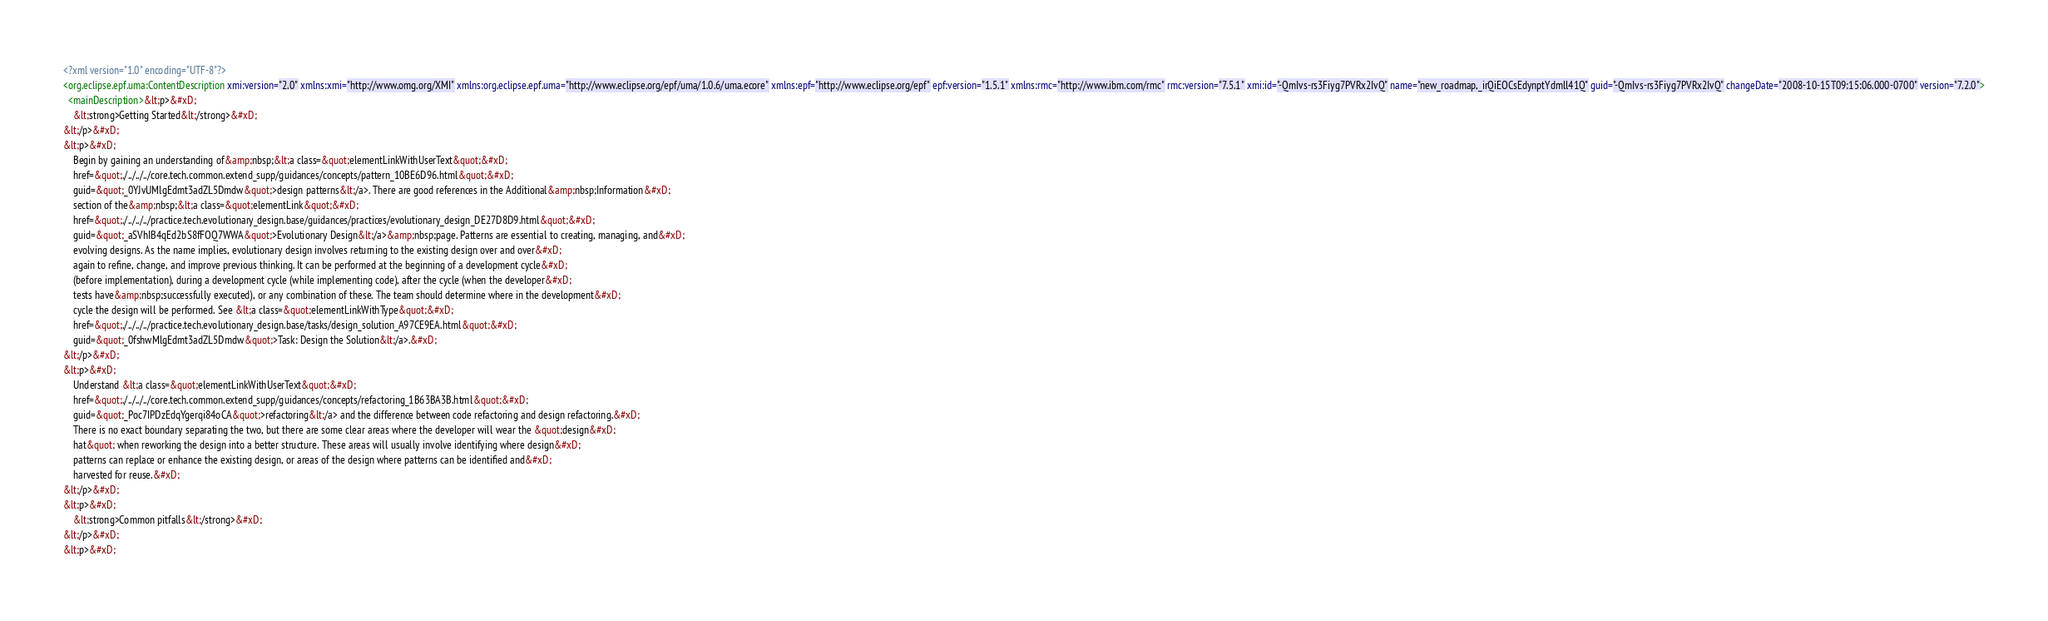<code> <loc_0><loc_0><loc_500><loc_500><_XML_><?xml version="1.0" encoding="UTF-8"?>
<org.eclipse.epf.uma:ContentDescription xmi:version="2.0" xmlns:xmi="http://www.omg.org/XMI" xmlns:org.eclipse.epf.uma="http://www.eclipse.org/epf/uma/1.0.6/uma.ecore" xmlns:epf="http://www.eclipse.org/epf" epf:version="1.5.1" xmlns:rmc="http://www.ibm.com/rmc" rmc:version="7.5.1" xmi:id="-QmIvs-rs3Fiyg7PVRx2IvQ" name="new_roadmap,_irQiEOCsEdynptYdmll41Q" guid="-QmIvs-rs3Fiyg7PVRx2IvQ" changeDate="2008-10-15T09:15:06.000-0700" version="7.2.0">
  <mainDescription>&lt;p>&#xD;
    &lt;strong>Getting Started&lt;/strong>&#xD;
&lt;/p>&#xD;
&lt;p>&#xD;
    Begin by gaining an understanding of&amp;nbsp;&lt;a class=&quot;elementLinkWithUserText&quot;&#xD;
    href=&quot;./../../../core.tech.common.extend_supp/guidances/concepts/pattern_10BE6D96.html&quot;&#xD;
    guid=&quot;_0YJvUMlgEdmt3adZL5Dmdw&quot;>design patterns&lt;/a>. There are good references in the Additional&amp;nbsp;Information&#xD;
    section of the&amp;nbsp;&lt;a class=&quot;elementLink&quot;&#xD;
    href=&quot;./../../../practice.tech.evolutionary_design.base/guidances/practices/evolutionary_design_DE27D8D9.html&quot;&#xD;
    guid=&quot;_aSVhIB4qEd2bS8fFOQ7WWA&quot;>Evolutionary Design&lt;/a>&amp;nbsp;page. Patterns are essential to creating, managing, and&#xD;
    evolving designs. As the name implies, evolutionary design involves returning to the existing design over and over&#xD;
    again to refine, change, and improve previous thinking. It can be performed at the beginning of a development cycle&#xD;
    (before implementation), during a development cycle (while implementing code), after the cycle (when the developer&#xD;
    tests have&amp;nbsp;successfully executed), or any combination of these. The team should determine where in the development&#xD;
    cycle the design will be performed. See &lt;a class=&quot;elementLinkWithType&quot;&#xD;
    href=&quot;./../../../practice.tech.evolutionary_design.base/tasks/design_solution_A97CE9EA.html&quot;&#xD;
    guid=&quot;_0fshwMlgEdmt3adZL5Dmdw&quot;>Task: Design the Solution&lt;/a>.&#xD;
&lt;/p>&#xD;
&lt;p>&#xD;
    Understand &lt;a class=&quot;elementLinkWithUserText&quot;&#xD;
    href=&quot;./../../../core.tech.common.extend_supp/guidances/concepts/refactoring_1B63BA3B.html&quot;&#xD;
    guid=&quot;_Poc7IPDzEdqYgerqi84oCA&quot;>refactoring&lt;/a> and the difference between code refactoring and design refactoring.&#xD;
    There is no exact boundary separating the two, but there are some clear areas where the developer will wear the &quot;design&#xD;
    hat&quot; when reworking the design into a better structure. These areas will usually involve identifying where design&#xD;
    patterns can replace or enhance the existing design, or areas of the design where patterns can be identified and&#xD;
    harvested for reuse.&#xD;
&lt;/p>&#xD;
&lt;p>&#xD;
    &lt;strong>Common pitfalls&lt;/strong>&#xD;
&lt;/p>&#xD;
&lt;p>&#xD;</code> 